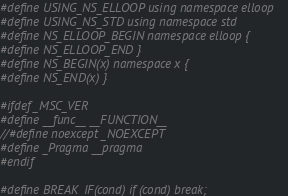<code> <loc_0><loc_0><loc_500><loc_500><_C_>#define USING_NS_ELLOOP using namespace elloop
#define USING_NS_STD using namespace std
#define NS_ELLOOP_BEGIN namespace elloop {
#define NS_ELLOOP_END }
#define NS_BEGIN(x) namespace x {
#define NS_END(x) }

#ifdef _MSC_VER
#define __func__ __FUNCTION__
//#define noexcept _NOEXCEPT
#define _Pragma __pragma 
#endif

#define BREAK_IF(cond) if (cond) break;
</code> 